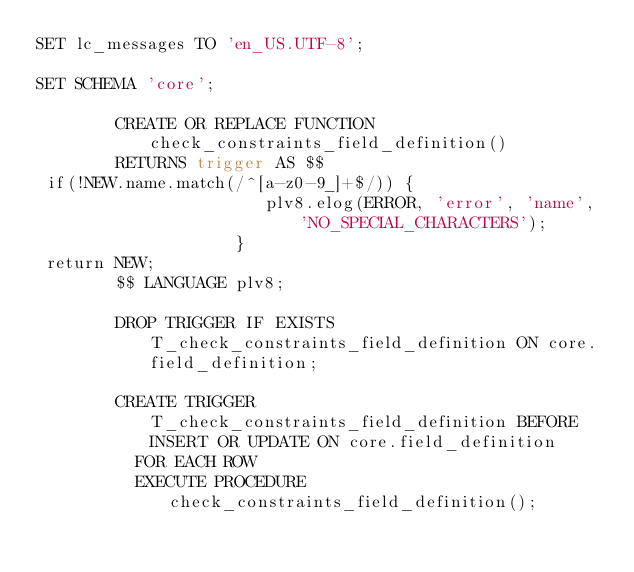<code> <loc_0><loc_0><loc_500><loc_500><_SQL_>SET lc_messages TO 'en_US.UTF-8';

SET SCHEMA 'core';

        CREATE OR REPLACE FUNCTION check_constraints_field_definition()
        RETURNS trigger AS $$
 if(!NEW.name.match(/^[a-z0-9_]+$/)) {
                       plv8.elog(ERROR, 'error', 'name', 'NO_SPECIAL_CHARACTERS');
                    }
 return NEW;
        $$ LANGUAGE plv8;

        DROP TRIGGER IF EXISTS T_check_constraints_field_definition ON core.field_definition;

        CREATE TRIGGER T_check_constraints_field_definition BEFORE INSERT OR UPDATE ON core.field_definition
          FOR EACH ROW
          EXECUTE PROCEDURE check_constraints_field_definition();
</code> 